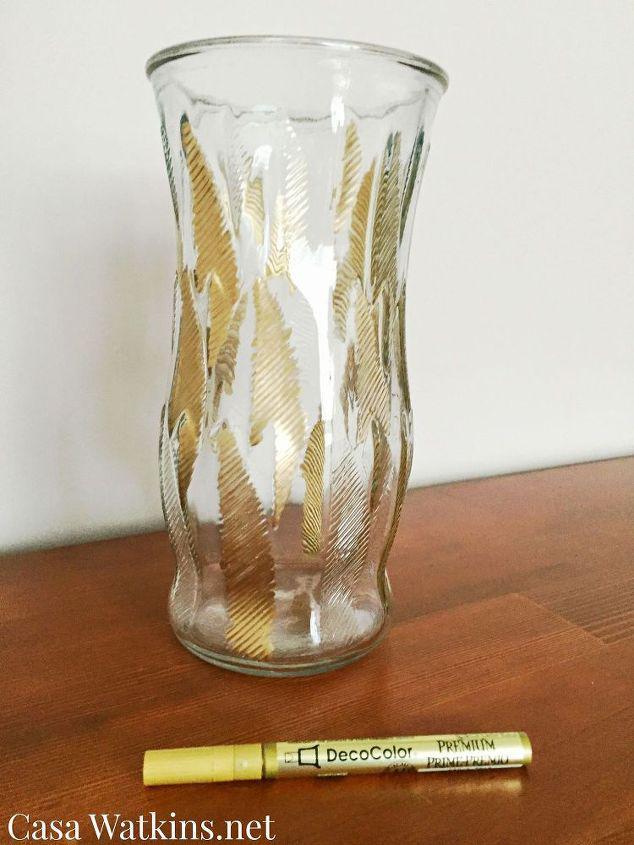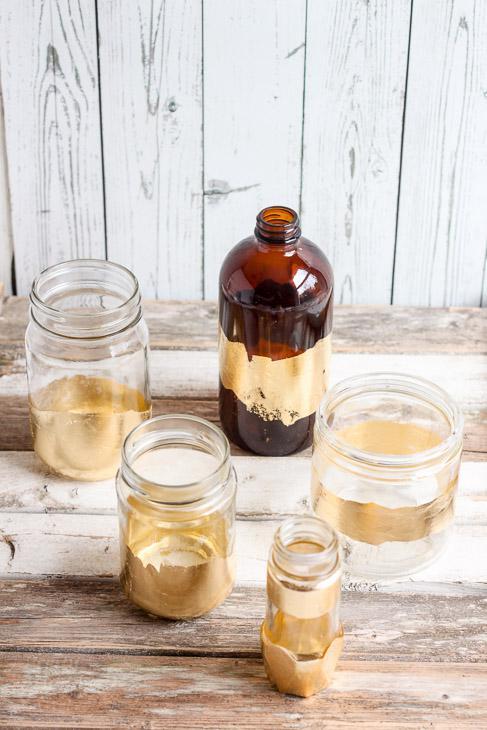The first image is the image on the left, the second image is the image on the right. Assess this claim about the two images: "Several plants sit in vases in the image on the right.". Correct or not? Answer yes or no. No. The first image is the image on the left, the second image is the image on the right. Given the left and right images, does the statement "At least one planter has a succulent in it." hold true? Answer yes or no. No. 